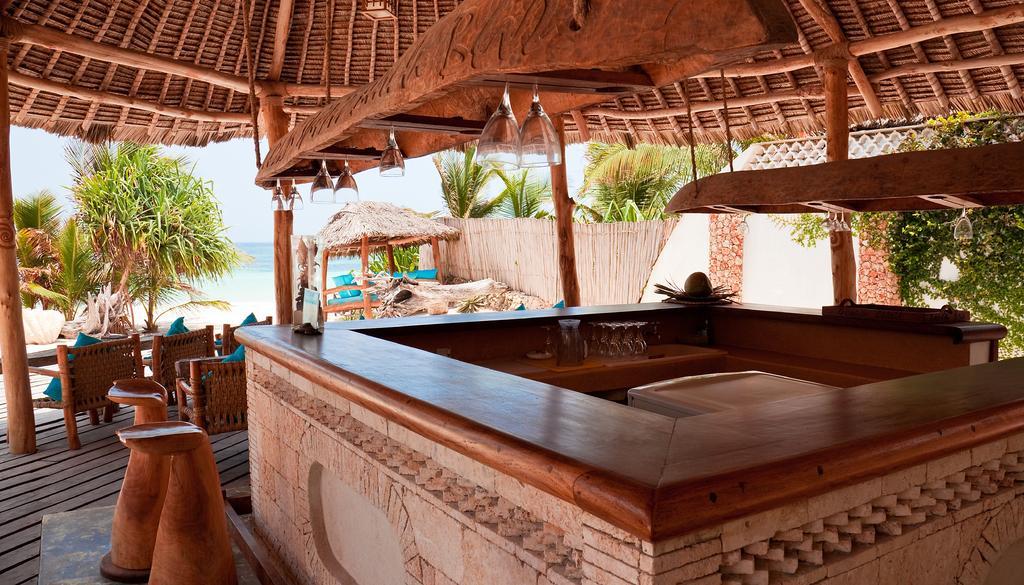Can you describe this image briefly? In this picture we can see some huts, in which we can see some chairs are arranged along with the tables, we can see some trees and water. 